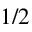<formula> <loc_0><loc_0><loc_500><loc_500>1 / 2</formula> 